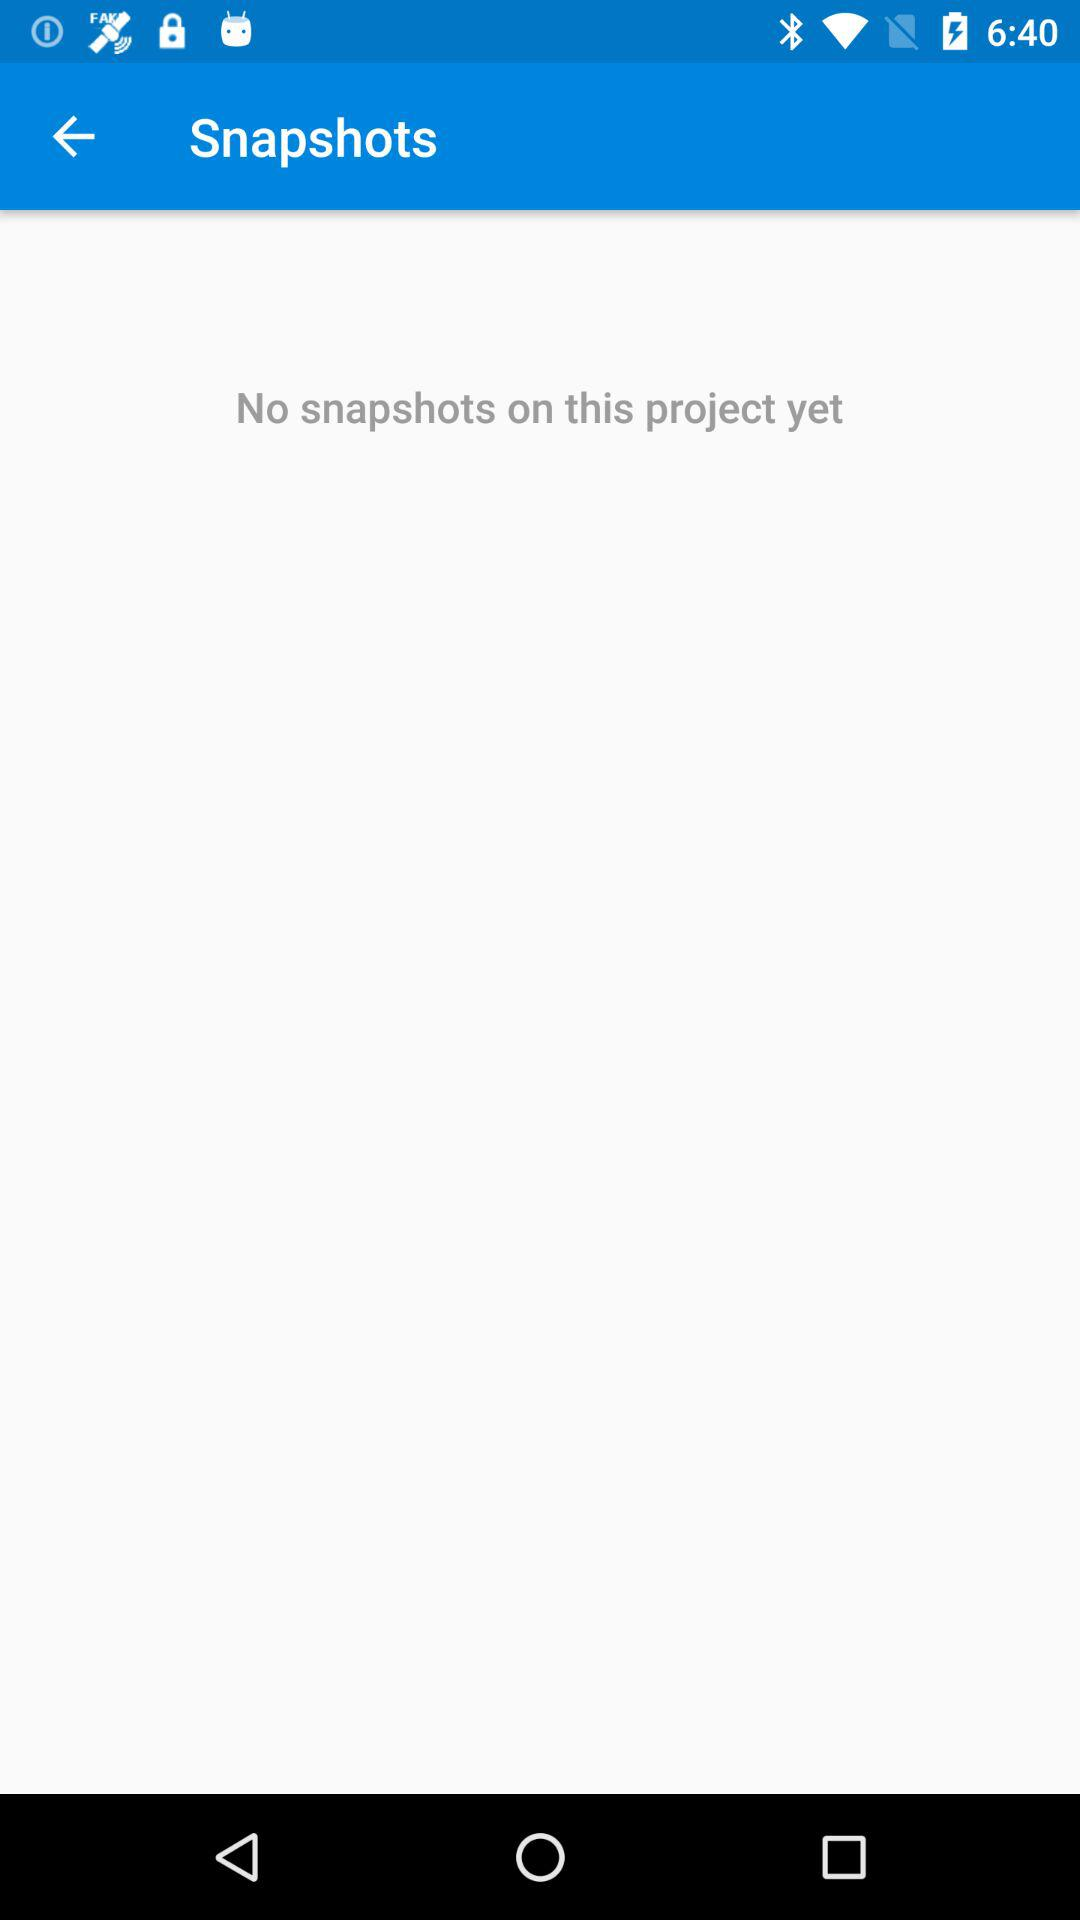Are there any snapshots? There are no snapshots. 